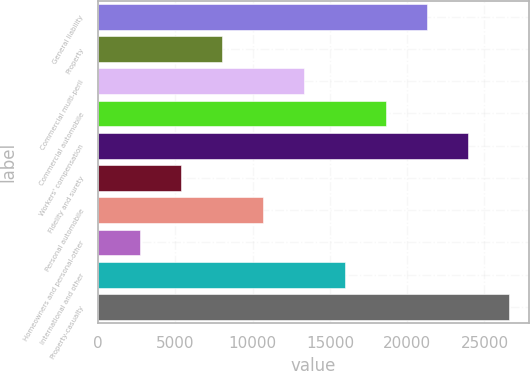<chart> <loc_0><loc_0><loc_500><loc_500><bar_chart><fcel>General liability<fcel>Property<fcel>Commercial multi-peril<fcel>Commercial automobile<fcel>Workers' compensation<fcel>Fidelity and surety<fcel>Personal automobile<fcel>Homeowners and personal-other<fcel>International and other<fcel>Property-casualty<nl><fcel>21259.2<fcel>8014.7<fcel>13312.5<fcel>18610.3<fcel>23908.1<fcel>5365.8<fcel>10663.6<fcel>2716.9<fcel>15961.4<fcel>26557<nl></chart> 